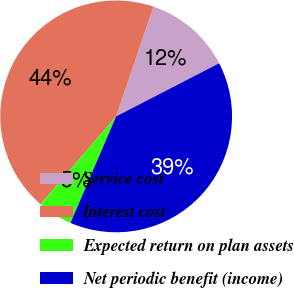<chart> <loc_0><loc_0><loc_500><loc_500><pie_chart><fcel>Service cost<fcel>Interest cost<fcel>Expected return on plan assets<fcel>Net periodic benefit (income)<nl><fcel>12.2%<fcel>43.9%<fcel>4.88%<fcel>39.02%<nl></chart> 